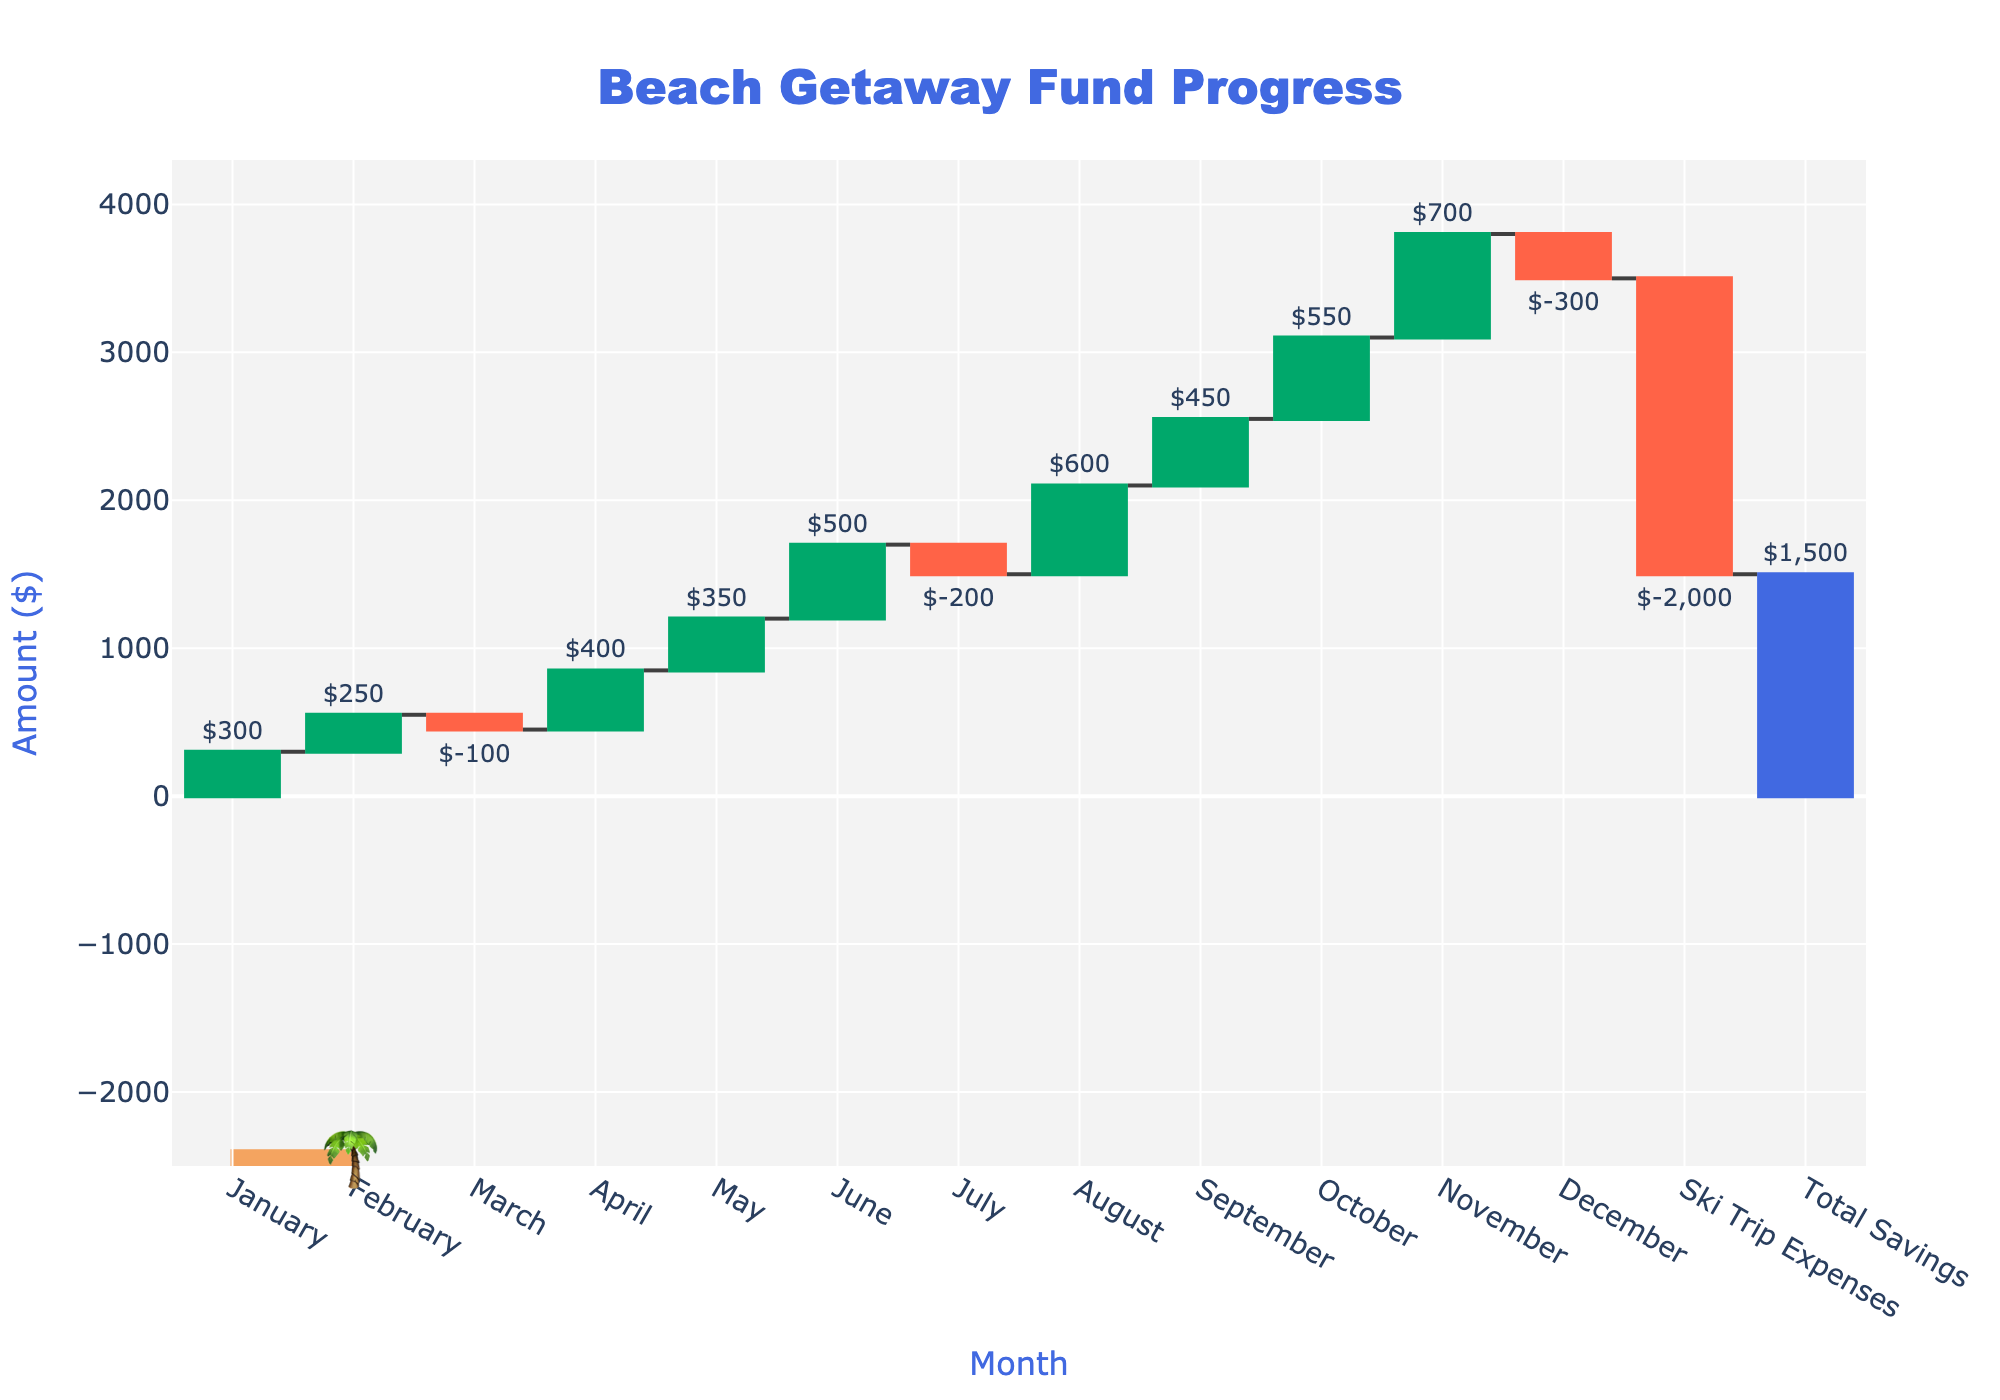What is the title of the chart? The title is usually at the top of the chart and provides a summary of what the figure represents. In this chart, it is clearly mentioned at the top.
Answer: Beach Getaway Fund Progress What month had the highest savings? By scanning the columns, look for the one with the tallest green bar because it shows the highest contribution. In the chart, August has the highest savings.
Answer: August What is the total amount spent on the Ski Trip? The Ski Trip Expenses should be indicated in the data with a red column showing a negative amount, clearly labeled in the chart.
Answer: $2000 Which month had the largest decrease in savings, and by how much? Look for the month with the longest red bar as it represents a decrease. March and December show decreases, but March has a decrease of $100 and December has $300, making December the largest.
Answer: December, $300 How much did you save in total by the end of the year? The total savings amount is often summarized at the end of the chart. Here, it's marked as "Total Savings" with the cumulative sum at the end.
Answer: $1500 What is the cumulative savings by the end of October? The cumulative savings can be tracked by following the running total up to October in the chart. Add the monthly values from January through October to verify.
Answer: $2500 Which month had the second highest savings? Look for the second tallest green bar in the chart. The highest is in August, and the next highest is in November.
Answer: November Compare the total savings after June to after August. Find the cumulative total at the end of June and August and compare them. June ends at $1700, and August ends at $2100. The difference from June to August is an increase of $400.
Answer: $1700 (June) and $2100 (August) How did the expenses for the Ski Trip affect the total savings? The Ski Trip Expenses is a large red bar near the end, and the total savings immediately before and after can be compared directly on the chart. Before the Ski Trip, savings are $3500 and after $1500. The trip reduces the savings by $2000.
Answer: It reduced total savings by $2000 What month had negative savings other than March, and what was the amount? Look for another red bar apart from the one found in March. July and December show negative savings, and the amounts are indicated. July has $200 and December has $300, so December is another month.
Answer: July, $200 